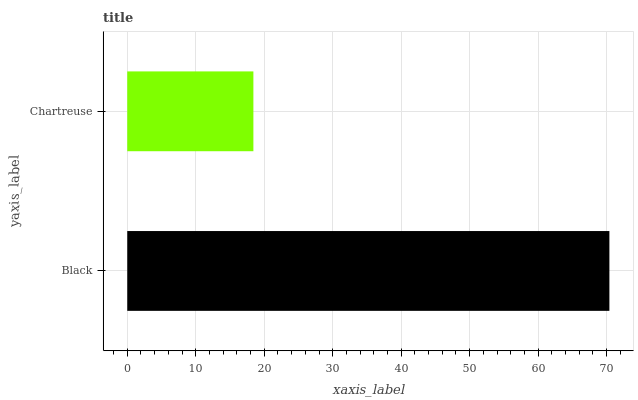Is Chartreuse the minimum?
Answer yes or no. Yes. Is Black the maximum?
Answer yes or no. Yes. Is Chartreuse the maximum?
Answer yes or no. No. Is Black greater than Chartreuse?
Answer yes or no. Yes. Is Chartreuse less than Black?
Answer yes or no. Yes. Is Chartreuse greater than Black?
Answer yes or no. No. Is Black less than Chartreuse?
Answer yes or no. No. Is Black the high median?
Answer yes or no. Yes. Is Chartreuse the low median?
Answer yes or no. Yes. Is Chartreuse the high median?
Answer yes or no. No. Is Black the low median?
Answer yes or no. No. 